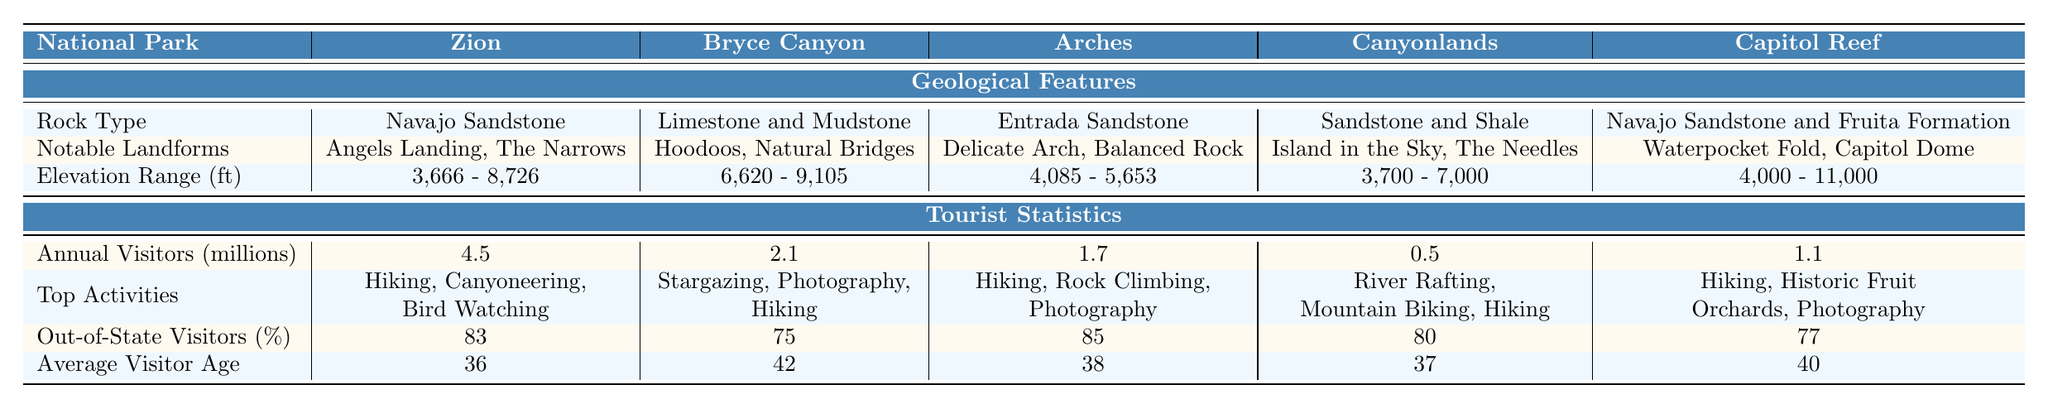What is the rock type found in Zion National Park? The table lists the geological features for each park. For Zion National Park, the rock type is specified as "Navajo Sandstone."
Answer: Navajo Sandstone Which park has the highest elevation range? To find the park with the highest elevation range, we compare the elevation ranges provided for each park. Capitol Reef National Park has an elevation range of "4,000 - 11,000 ft," which is the largest.
Answer: Capitol Reef National Park How many annual visitors does Canyonlands National Park receive? The table shows the tourist statistics for each park. Canyonlands National Park has "0.5" million annual visitors.
Answer: 0.5 million Which national park has the oldest average visitor age? The table presents the average visitor age for all parks. Bryce Canyon National Park has an average age of "42," which is the highest compared to other parks.
Answer: Bryce Canyon National Park What is the average age of visitors across all parks? To calculate the average age, sum the average ages for each park (36 + 42 + 38 + 37 + 40 = 193) and divide by the number of parks (5). The average age is 193/5 = 38.6, which approximates to 39 when rounded.
Answer: 39 Is it true that more than 80% of visitors to Arches National Park are from out of state? The table indicates that the percentage of out-of-state visitors to Arches National Park is 85%. Since 85% is greater than 80%, the statement is true.
Answer: Yes Which park has the least annual visitors? The table provides annual visitor statistics for each park. Canyonlands National Park with "0.5" million annual visitors has the least number of visitors compared to others.
Answer: Canyonlands National Park If we consider the top activities, which park includes "Bird Watching"? The table lists the top activities for each park, and Bird Watching is mentioned as a top activity for Zion National Park.
Answer: Zion National Park Calculate the difference in annual visitors between Zion National Park and Bryce Canyon National Park. Zion National Park has 4.5 million visitors, and Bryce Canyon National Park has 2.1 million. The difference is 4.5 - 2.1 = 2.4 million.
Answer: 2.4 million Which park features the "Hoodoos"? The notable landforms for each park are shown in the table. "Hoodoos" are specifically listed under Bryce Canyon National Park.
Answer: Bryce Canyon National Park 